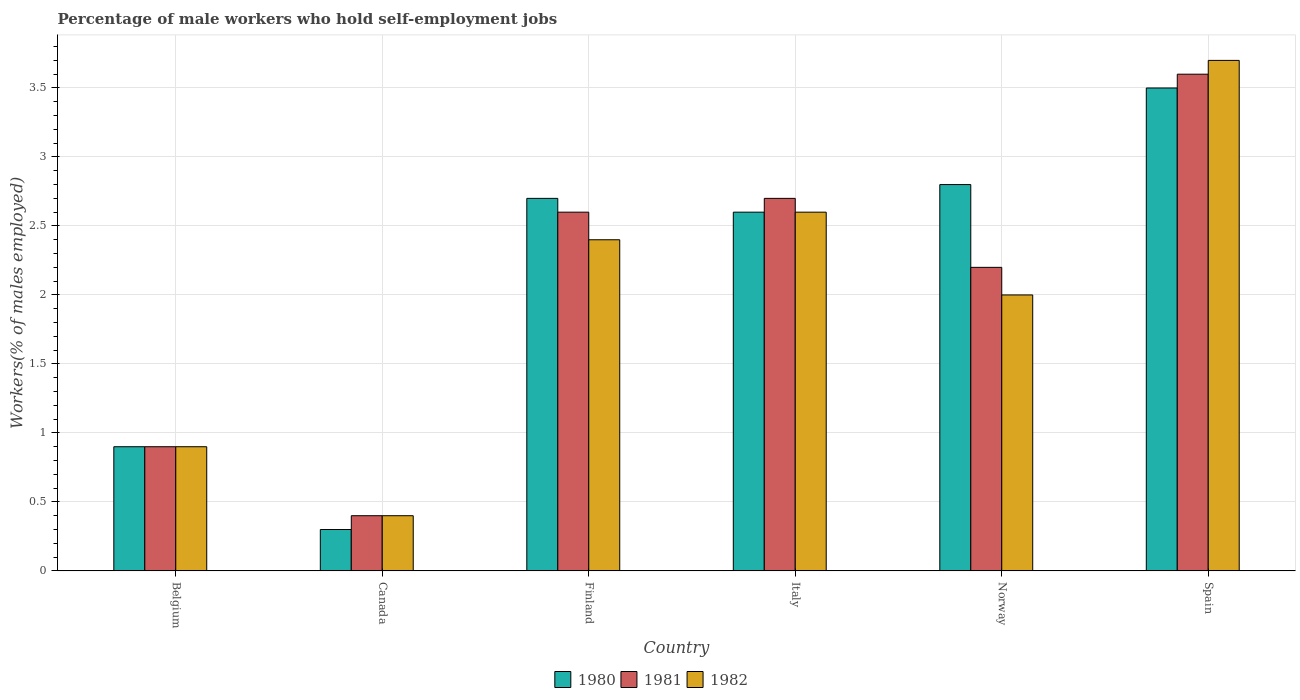How many bars are there on the 2nd tick from the right?
Make the answer very short. 3. What is the label of the 1st group of bars from the left?
Make the answer very short. Belgium. What is the percentage of self-employed male workers in 1981 in Canada?
Offer a terse response. 0.4. Across all countries, what is the maximum percentage of self-employed male workers in 1981?
Make the answer very short. 3.6. Across all countries, what is the minimum percentage of self-employed male workers in 1980?
Ensure brevity in your answer.  0.3. What is the total percentage of self-employed male workers in 1980 in the graph?
Offer a very short reply. 12.8. What is the difference between the percentage of self-employed male workers in 1982 in Canada and that in Norway?
Offer a terse response. -1.6. What is the difference between the percentage of self-employed male workers in 1981 in Norway and the percentage of self-employed male workers in 1982 in Canada?
Make the answer very short. 1.8. What is the average percentage of self-employed male workers in 1980 per country?
Ensure brevity in your answer.  2.13. What is the difference between the percentage of self-employed male workers of/in 1982 and percentage of self-employed male workers of/in 1981 in Finland?
Ensure brevity in your answer.  -0.2. What is the ratio of the percentage of self-employed male workers in 1982 in Italy to that in Spain?
Keep it short and to the point. 0.7. Is the percentage of self-employed male workers in 1982 in Belgium less than that in Norway?
Provide a succinct answer. Yes. Is the difference between the percentage of self-employed male workers in 1982 in Belgium and Italy greater than the difference between the percentage of self-employed male workers in 1981 in Belgium and Italy?
Give a very brief answer. Yes. What is the difference between the highest and the second highest percentage of self-employed male workers in 1982?
Ensure brevity in your answer.  -1.1. What is the difference between the highest and the lowest percentage of self-employed male workers in 1982?
Offer a terse response. 3.3. Is the sum of the percentage of self-employed male workers in 1981 in Finland and Italy greater than the maximum percentage of self-employed male workers in 1980 across all countries?
Keep it short and to the point. Yes. Is it the case that in every country, the sum of the percentage of self-employed male workers in 1980 and percentage of self-employed male workers in 1982 is greater than the percentage of self-employed male workers in 1981?
Your response must be concise. Yes. How many bars are there?
Give a very brief answer. 18. How many countries are there in the graph?
Give a very brief answer. 6. Are the values on the major ticks of Y-axis written in scientific E-notation?
Your response must be concise. No. Does the graph contain any zero values?
Offer a terse response. No. Does the graph contain grids?
Provide a short and direct response. Yes. Where does the legend appear in the graph?
Provide a short and direct response. Bottom center. How many legend labels are there?
Give a very brief answer. 3. How are the legend labels stacked?
Ensure brevity in your answer.  Horizontal. What is the title of the graph?
Keep it short and to the point. Percentage of male workers who hold self-employment jobs. What is the label or title of the X-axis?
Your answer should be compact. Country. What is the label or title of the Y-axis?
Offer a terse response. Workers(% of males employed). What is the Workers(% of males employed) of 1980 in Belgium?
Your answer should be very brief. 0.9. What is the Workers(% of males employed) of 1981 in Belgium?
Keep it short and to the point. 0.9. What is the Workers(% of males employed) of 1982 in Belgium?
Offer a very short reply. 0.9. What is the Workers(% of males employed) in 1980 in Canada?
Keep it short and to the point. 0.3. What is the Workers(% of males employed) in 1981 in Canada?
Your answer should be compact. 0.4. What is the Workers(% of males employed) of 1982 in Canada?
Your answer should be compact. 0.4. What is the Workers(% of males employed) in 1980 in Finland?
Keep it short and to the point. 2.7. What is the Workers(% of males employed) of 1981 in Finland?
Keep it short and to the point. 2.6. What is the Workers(% of males employed) of 1982 in Finland?
Give a very brief answer. 2.4. What is the Workers(% of males employed) in 1980 in Italy?
Offer a terse response. 2.6. What is the Workers(% of males employed) of 1981 in Italy?
Ensure brevity in your answer.  2.7. What is the Workers(% of males employed) in 1982 in Italy?
Provide a short and direct response. 2.6. What is the Workers(% of males employed) of 1980 in Norway?
Make the answer very short. 2.8. What is the Workers(% of males employed) of 1981 in Norway?
Keep it short and to the point. 2.2. What is the Workers(% of males employed) in 1982 in Norway?
Provide a succinct answer. 2. What is the Workers(% of males employed) of 1980 in Spain?
Your answer should be compact. 3.5. What is the Workers(% of males employed) of 1981 in Spain?
Give a very brief answer. 3.6. What is the Workers(% of males employed) in 1982 in Spain?
Provide a succinct answer. 3.7. Across all countries, what is the maximum Workers(% of males employed) in 1981?
Provide a short and direct response. 3.6. Across all countries, what is the maximum Workers(% of males employed) of 1982?
Your answer should be compact. 3.7. Across all countries, what is the minimum Workers(% of males employed) of 1980?
Offer a very short reply. 0.3. Across all countries, what is the minimum Workers(% of males employed) of 1981?
Your answer should be very brief. 0.4. Across all countries, what is the minimum Workers(% of males employed) of 1982?
Give a very brief answer. 0.4. What is the total Workers(% of males employed) of 1980 in the graph?
Your answer should be very brief. 12.8. What is the total Workers(% of males employed) of 1982 in the graph?
Offer a terse response. 12. What is the difference between the Workers(% of males employed) of 1980 in Belgium and that in Canada?
Your response must be concise. 0.6. What is the difference between the Workers(% of males employed) of 1981 in Belgium and that in Canada?
Provide a succinct answer. 0.5. What is the difference between the Workers(% of males employed) in 1980 in Belgium and that in Finland?
Your answer should be very brief. -1.8. What is the difference between the Workers(% of males employed) in 1981 in Belgium and that in Italy?
Provide a short and direct response. -1.8. What is the difference between the Workers(% of males employed) in 1980 in Belgium and that in Spain?
Provide a succinct answer. -2.6. What is the difference between the Workers(% of males employed) of 1981 in Canada and that in Finland?
Offer a terse response. -2.2. What is the difference between the Workers(% of males employed) in 1982 in Canada and that in Italy?
Offer a terse response. -2.2. What is the difference between the Workers(% of males employed) in 1980 in Canada and that in Norway?
Your response must be concise. -2.5. What is the difference between the Workers(% of males employed) in 1981 in Canada and that in Norway?
Your answer should be very brief. -1.8. What is the difference between the Workers(% of males employed) of 1982 in Finland and that in Italy?
Your response must be concise. -0.2. What is the difference between the Workers(% of males employed) in 1980 in Finland and that in Spain?
Your answer should be very brief. -0.8. What is the difference between the Workers(% of males employed) in 1980 in Italy and that in Norway?
Your answer should be compact. -0.2. What is the difference between the Workers(% of males employed) of 1980 in Italy and that in Spain?
Your answer should be compact. -0.9. What is the difference between the Workers(% of males employed) in 1981 in Italy and that in Spain?
Your answer should be compact. -0.9. What is the difference between the Workers(% of males employed) in 1982 in Italy and that in Spain?
Keep it short and to the point. -1.1. What is the difference between the Workers(% of males employed) in 1982 in Norway and that in Spain?
Provide a succinct answer. -1.7. What is the difference between the Workers(% of males employed) of 1980 in Belgium and the Workers(% of males employed) of 1981 in Canada?
Provide a succinct answer. 0.5. What is the difference between the Workers(% of males employed) in 1981 in Belgium and the Workers(% of males employed) in 1982 in Canada?
Your answer should be very brief. 0.5. What is the difference between the Workers(% of males employed) of 1980 in Belgium and the Workers(% of males employed) of 1982 in Italy?
Offer a very short reply. -1.7. What is the difference between the Workers(% of males employed) in 1981 in Belgium and the Workers(% of males employed) in 1982 in Italy?
Your answer should be compact. -1.7. What is the difference between the Workers(% of males employed) in 1980 in Belgium and the Workers(% of males employed) in 1982 in Norway?
Ensure brevity in your answer.  -1.1. What is the difference between the Workers(% of males employed) of 1980 in Belgium and the Workers(% of males employed) of 1981 in Spain?
Offer a terse response. -2.7. What is the difference between the Workers(% of males employed) in 1980 in Belgium and the Workers(% of males employed) in 1982 in Spain?
Keep it short and to the point. -2.8. What is the difference between the Workers(% of males employed) in 1980 in Canada and the Workers(% of males employed) in 1981 in Finland?
Provide a succinct answer. -2.3. What is the difference between the Workers(% of males employed) in 1980 in Canada and the Workers(% of males employed) in 1982 in Finland?
Ensure brevity in your answer.  -2.1. What is the difference between the Workers(% of males employed) of 1981 in Canada and the Workers(% of males employed) of 1982 in Finland?
Offer a terse response. -2. What is the difference between the Workers(% of males employed) in 1980 in Canada and the Workers(% of males employed) in 1981 in Italy?
Make the answer very short. -2.4. What is the difference between the Workers(% of males employed) of 1980 in Canada and the Workers(% of males employed) of 1982 in Italy?
Your answer should be very brief. -2.3. What is the difference between the Workers(% of males employed) in 1980 in Finland and the Workers(% of males employed) in 1982 in Italy?
Offer a very short reply. 0.1. What is the difference between the Workers(% of males employed) in 1980 in Finland and the Workers(% of males employed) in 1982 in Norway?
Offer a terse response. 0.7. What is the difference between the Workers(% of males employed) of 1980 in Finland and the Workers(% of males employed) of 1981 in Spain?
Provide a short and direct response. -0.9. What is the difference between the Workers(% of males employed) in 1980 in Finland and the Workers(% of males employed) in 1982 in Spain?
Ensure brevity in your answer.  -1. What is the difference between the Workers(% of males employed) in 1980 in Italy and the Workers(% of males employed) in 1981 in Norway?
Keep it short and to the point. 0.4. What is the difference between the Workers(% of males employed) in 1980 in Italy and the Workers(% of males employed) in 1982 in Norway?
Make the answer very short. 0.6. What is the difference between the Workers(% of males employed) in 1981 in Italy and the Workers(% of males employed) in 1982 in Norway?
Your response must be concise. 0.7. What is the difference between the Workers(% of males employed) in 1980 in Italy and the Workers(% of males employed) in 1981 in Spain?
Offer a very short reply. -1. What is the difference between the Workers(% of males employed) in 1981 in Italy and the Workers(% of males employed) in 1982 in Spain?
Your answer should be very brief. -1. What is the average Workers(% of males employed) of 1980 per country?
Your response must be concise. 2.13. What is the average Workers(% of males employed) in 1981 per country?
Your response must be concise. 2.07. What is the difference between the Workers(% of males employed) in 1980 and Workers(% of males employed) in 1982 in Belgium?
Offer a very short reply. 0. What is the difference between the Workers(% of males employed) of 1980 and Workers(% of males employed) of 1981 in Canada?
Offer a very short reply. -0.1. What is the difference between the Workers(% of males employed) of 1980 and Workers(% of males employed) of 1982 in Canada?
Ensure brevity in your answer.  -0.1. What is the difference between the Workers(% of males employed) of 1980 and Workers(% of males employed) of 1981 in Finland?
Your answer should be very brief. 0.1. What is the difference between the Workers(% of males employed) in 1980 and Workers(% of males employed) in 1982 in Finland?
Give a very brief answer. 0.3. What is the difference between the Workers(% of males employed) of 1981 and Workers(% of males employed) of 1982 in Finland?
Offer a very short reply. 0.2. What is the difference between the Workers(% of males employed) in 1980 and Workers(% of males employed) in 1981 in Italy?
Keep it short and to the point. -0.1. What is the difference between the Workers(% of males employed) of 1980 and Workers(% of males employed) of 1981 in Norway?
Ensure brevity in your answer.  0.6. What is the difference between the Workers(% of males employed) in 1980 and Workers(% of males employed) in 1982 in Norway?
Your response must be concise. 0.8. What is the difference between the Workers(% of males employed) of 1981 and Workers(% of males employed) of 1982 in Spain?
Ensure brevity in your answer.  -0.1. What is the ratio of the Workers(% of males employed) in 1980 in Belgium to that in Canada?
Provide a succinct answer. 3. What is the ratio of the Workers(% of males employed) in 1981 in Belgium to that in Canada?
Your answer should be very brief. 2.25. What is the ratio of the Workers(% of males employed) in 1982 in Belgium to that in Canada?
Give a very brief answer. 2.25. What is the ratio of the Workers(% of males employed) in 1980 in Belgium to that in Finland?
Give a very brief answer. 0.33. What is the ratio of the Workers(% of males employed) in 1981 in Belgium to that in Finland?
Ensure brevity in your answer.  0.35. What is the ratio of the Workers(% of males employed) of 1982 in Belgium to that in Finland?
Your response must be concise. 0.38. What is the ratio of the Workers(% of males employed) in 1980 in Belgium to that in Italy?
Provide a succinct answer. 0.35. What is the ratio of the Workers(% of males employed) of 1981 in Belgium to that in Italy?
Provide a short and direct response. 0.33. What is the ratio of the Workers(% of males employed) of 1982 in Belgium to that in Italy?
Keep it short and to the point. 0.35. What is the ratio of the Workers(% of males employed) of 1980 in Belgium to that in Norway?
Provide a succinct answer. 0.32. What is the ratio of the Workers(% of males employed) in 1981 in Belgium to that in Norway?
Offer a very short reply. 0.41. What is the ratio of the Workers(% of males employed) in 1982 in Belgium to that in Norway?
Your answer should be very brief. 0.45. What is the ratio of the Workers(% of males employed) in 1980 in Belgium to that in Spain?
Your answer should be very brief. 0.26. What is the ratio of the Workers(% of males employed) in 1981 in Belgium to that in Spain?
Your answer should be compact. 0.25. What is the ratio of the Workers(% of males employed) in 1982 in Belgium to that in Spain?
Make the answer very short. 0.24. What is the ratio of the Workers(% of males employed) of 1981 in Canada to that in Finland?
Your response must be concise. 0.15. What is the ratio of the Workers(% of males employed) in 1980 in Canada to that in Italy?
Keep it short and to the point. 0.12. What is the ratio of the Workers(% of males employed) of 1981 in Canada to that in Italy?
Your response must be concise. 0.15. What is the ratio of the Workers(% of males employed) in 1982 in Canada to that in Italy?
Your response must be concise. 0.15. What is the ratio of the Workers(% of males employed) in 1980 in Canada to that in Norway?
Your answer should be very brief. 0.11. What is the ratio of the Workers(% of males employed) in 1981 in Canada to that in Norway?
Give a very brief answer. 0.18. What is the ratio of the Workers(% of males employed) of 1980 in Canada to that in Spain?
Make the answer very short. 0.09. What is the ratio of the Workers(% of males employed) of 1982 in Canada to that in Spain?
Keep it short and to the point. 0.11. What is the ratio of the Workers(% of males employed) in 1981 in Finland to that in Italy?
Give a very brief answer. 0.96. What is the ratio of the Workers(% of males employed) in 1980 in Finland to that in Norway?
Keep it short and to the point. 0.96. What is the ratio of the Workers(% of males employed) of 1981 in Finland to that in Norway?
Provide a succinct answer. 1.18. What is the ratio of the Workers(% of males employed) in 1980 in Finland to that in Spain?
Your answer should be very brief. 0.77. What is the ratio of the Workers(% of males employed) in 1981 in Finland to that in Spain?
Offer a terse response. 0.72. What is the ratio of the Workers(% of males employed) of 1982 in Finland to that in Spain?
Keep it short and to the point. 0.65. What is the ratio of the Workers(% of males employed) in 1980 in Italy to that in Norway?
Ensure brevity in your answer.  0.93. What is the ratio of the Workers(% of males employed) of 1981 in Italy to that in Norway?
Ensure brevity in your answer.  1.23. What is the ratio of the Workers(% of males employed) in 1980 in Italy to that in Spain?
Offer a very short reply. 0.74. What is the ratio of the Workers(% of males employed) of 1981 in Italy to that in Spain?
Make the answer very short. 0.75. What is the ratio of the Workers(% of males employed) of 1982 in Italy to that in Spain?
Make the answer very short. 0.7. What is the ratio of the Workers(% of males employed) in 1980 in Norway to that in Spain?
Keep it short and to the point. 0.8. What is the ratio of the Workers(% of males employed) of 1981 in Norway to that in Spain?
Ensure brevity in your answer.  0.61. What is the ratio of the Workers(% of males employed) in 1982 in Norway to that in Spain?
Make the answer very short. 0.54. What is the difference between the highest and the second highest Workers(% of males employed) of 1980?
Give a very brief answer. 0.7. What is the difference between the highest and the second highest Workers(% of males employed) in 1981?
Provide a succinct answer. 0.9. What is the difference between the highest and the lowest Workers(% of males employed) in 1980?
Your answer should be very brief. 3.2. What is the difference between the highest and the lowest Workers(% of males employed) of 1982?
Your answer should be compact. 3.3. 